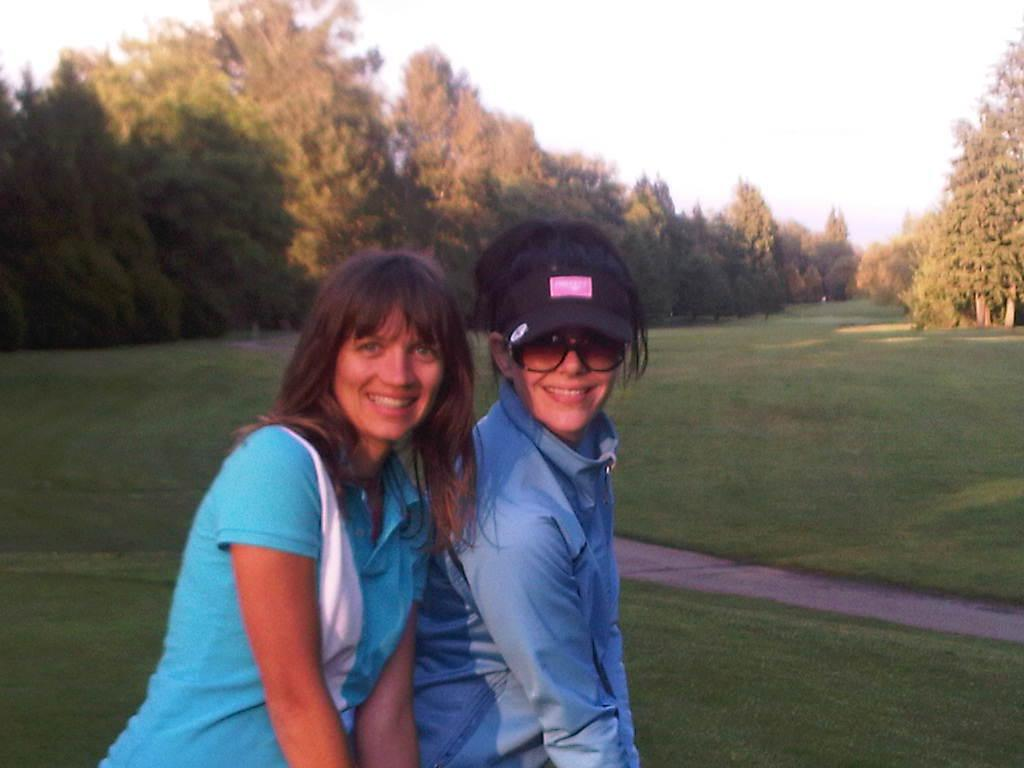How many women are present in the image? There are two women standing in the image. Can you describe the clothing or accessories of one of the women? One of the women is wearing a cap. What type of eyewear is visible on one of the women? One of the women is wearing sunglasses. What type of vegetation can be seen in the image? There are trees visible in the image. What is the ground covered with in the image? The ground is covered with grass in the image. How would you describe the sky in the image? The sky appears to be cloudy in the image. How many visitors are present in the image? There is no mention of visitors in the image; it only features two women. What type of error can be seen in the image? There is no error present in the image. 